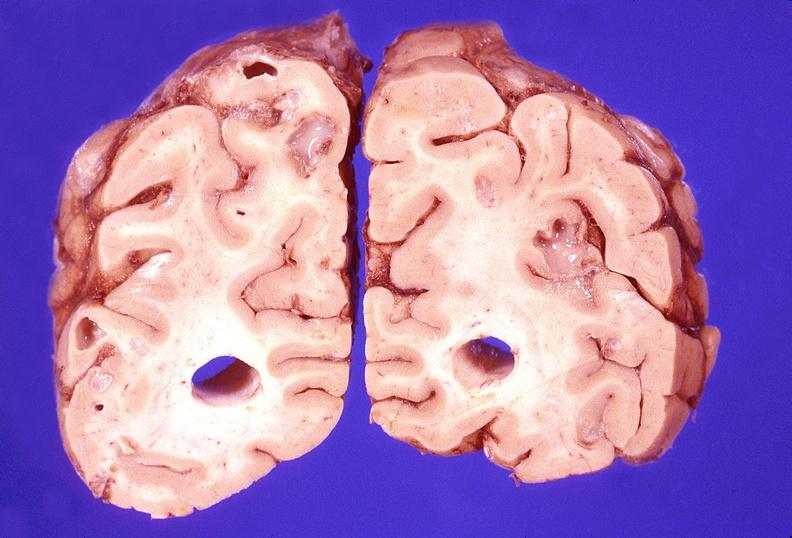does laceration show brain abscess?
Answer the question using a single word or phrase. No 